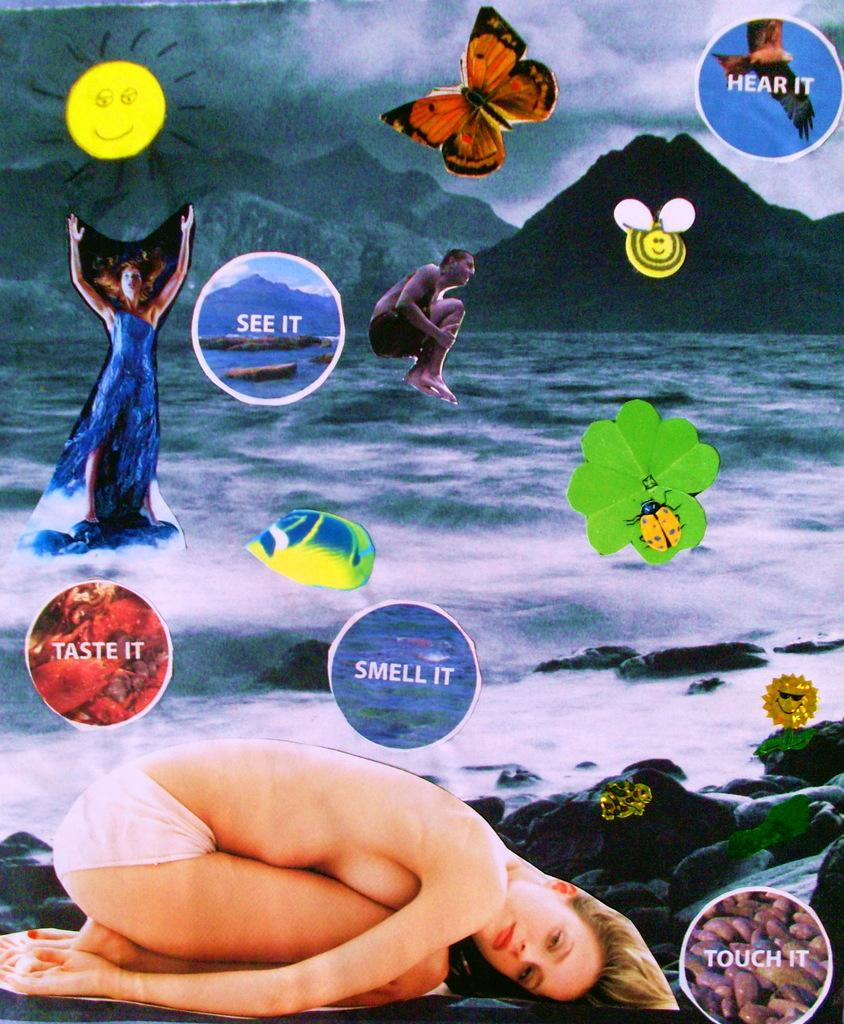What is pasted on the image? There are strikers pasted on the image. What can be seen in the background of the image? The background of the image contains mountains and a sea. How many yokes are visible in the image? There are no yokes present in the image. What type of juice can be seen being consumed by the strikers in the image? There is no juice being consumed by the strikers in the image; the focus is on the strikers themselves and the background. 